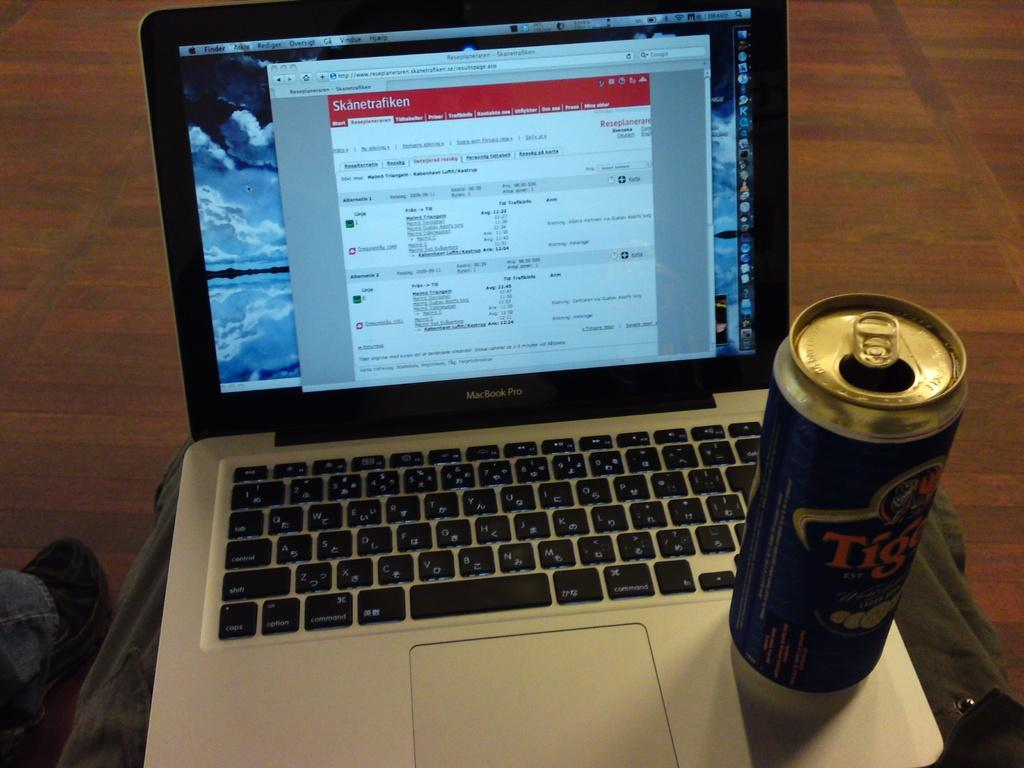<image>
Provide a brief description of the given image. A Macbook Pro is open and switched on with a can of Tiger lager balanced by the trackpad. 